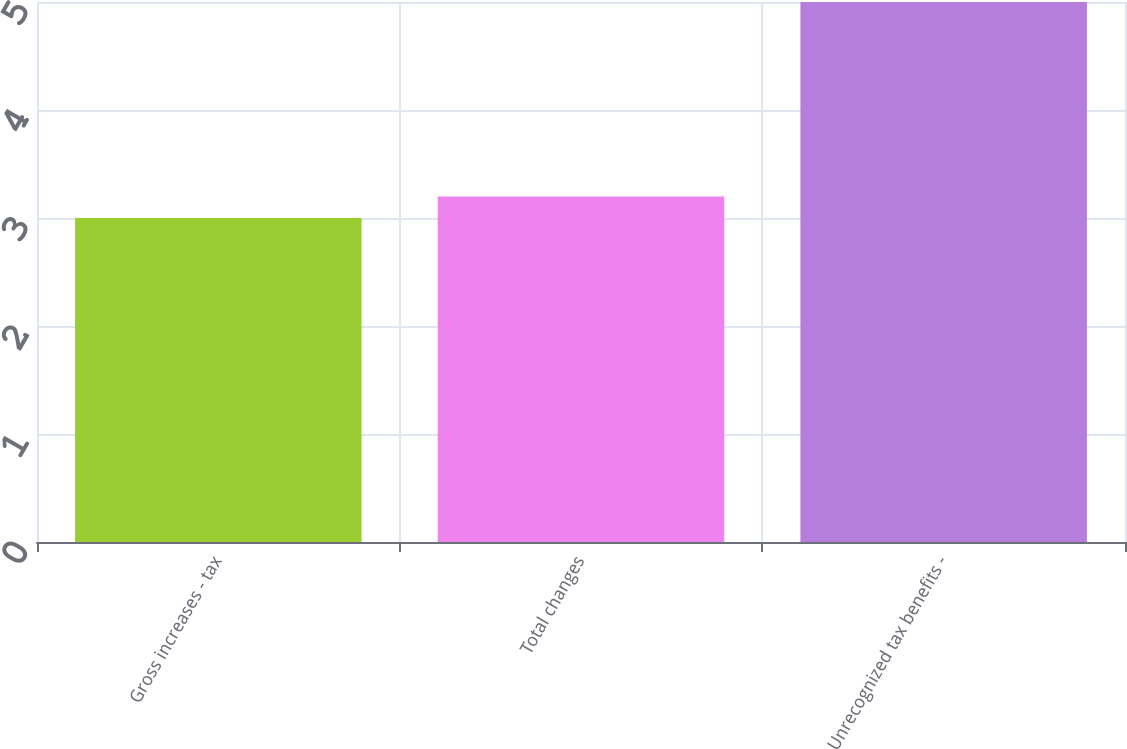Convert chart to OTSL. <chart><loc_0><loc_0><loc_500><loc_500><bar_chart><fcel>Gross increases - tax<fcel>Total changes<fcel>Unrecognized tax benefits -<nl><fcel>3<fcel>3.2<fcel>5<nl></chart> 